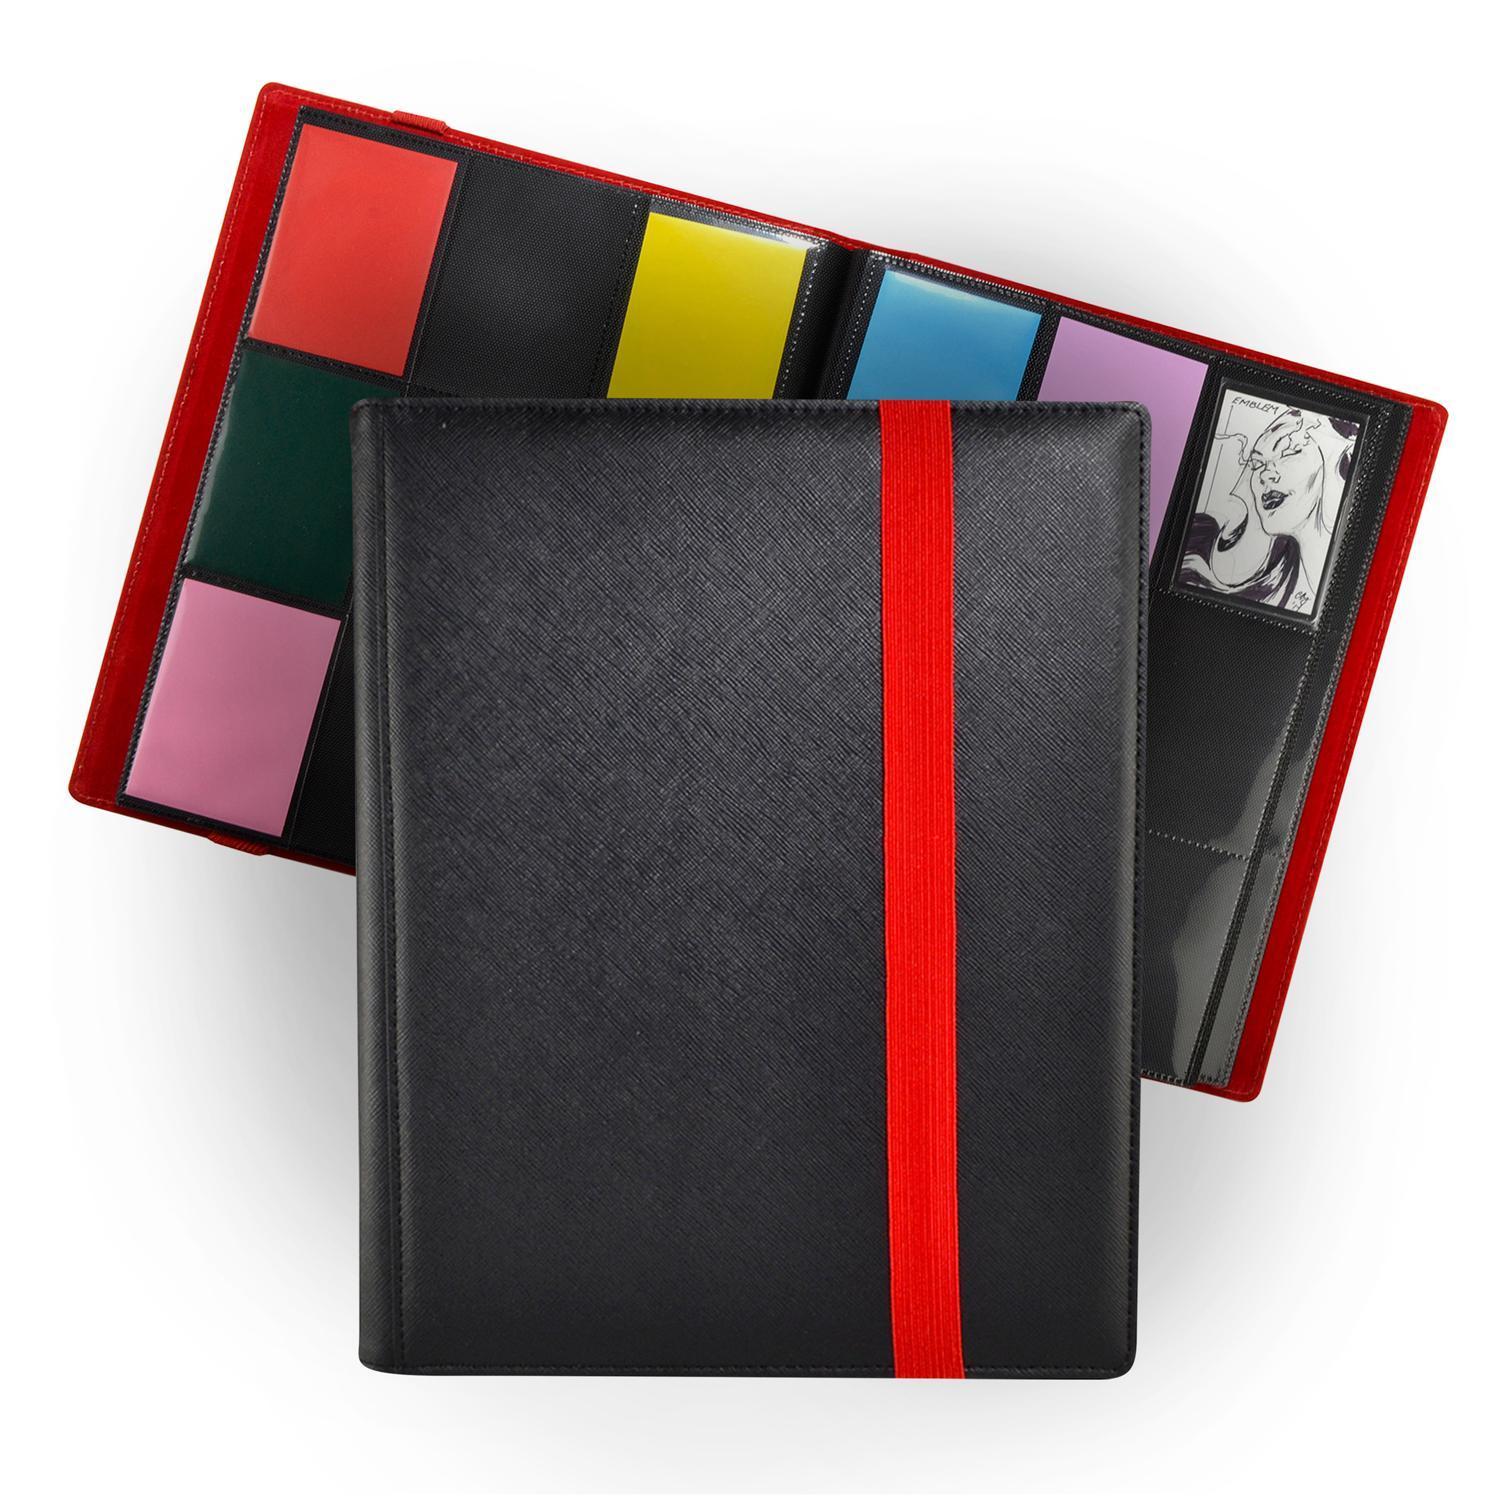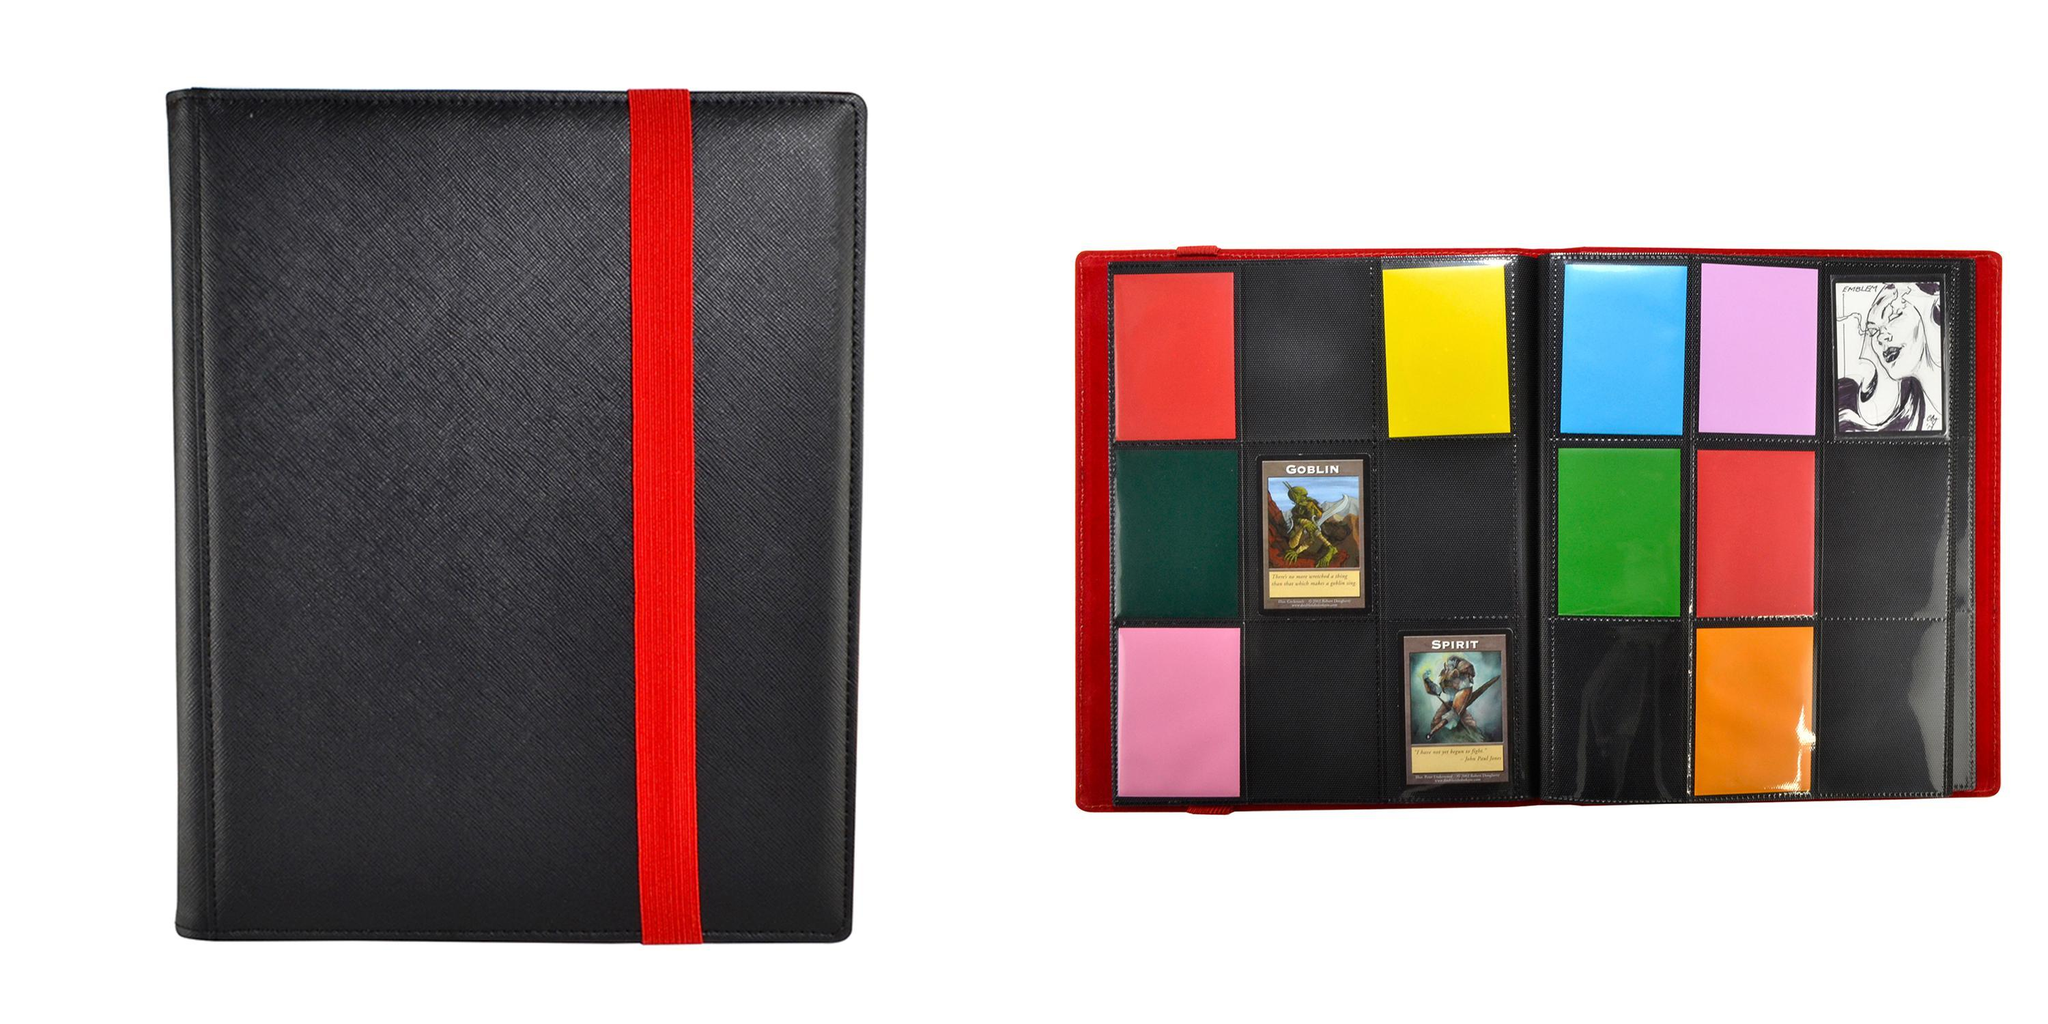The first image is the image on the left, the second image is the image on the right. Assess this claim about the two images: "Only one folder is on the left image.". Correct or not? Answer yes or no. No. 